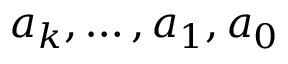<formula> <loc_0><loc_0><loc_500><loc_500>a _ { k } , \dots c , a _ { 1 } , a _ { 0 }</formula> 